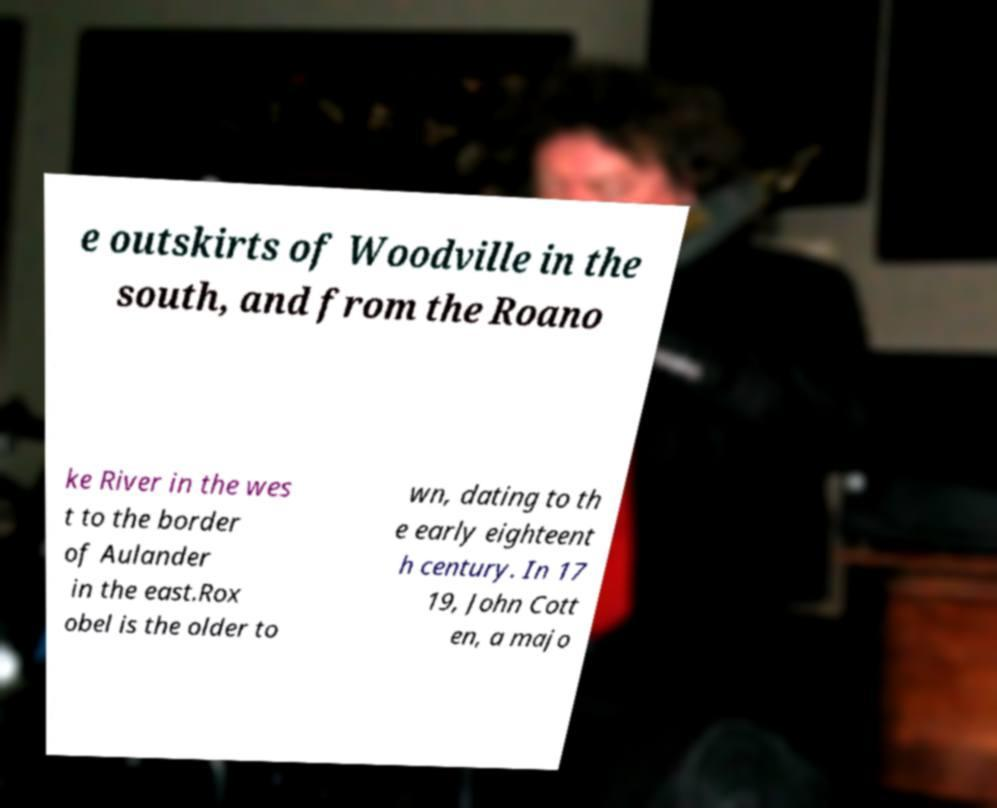For documentation purposes, I need the text within this image transcribed. Could you provide that? e outskirts of Woodville in the south, and from the Roano ke River in the wes t to the border of Aulander in the east.Rox obel is the older to wn, dating to th e early eighteent h century. In 17 19, John Cott en, a majo 